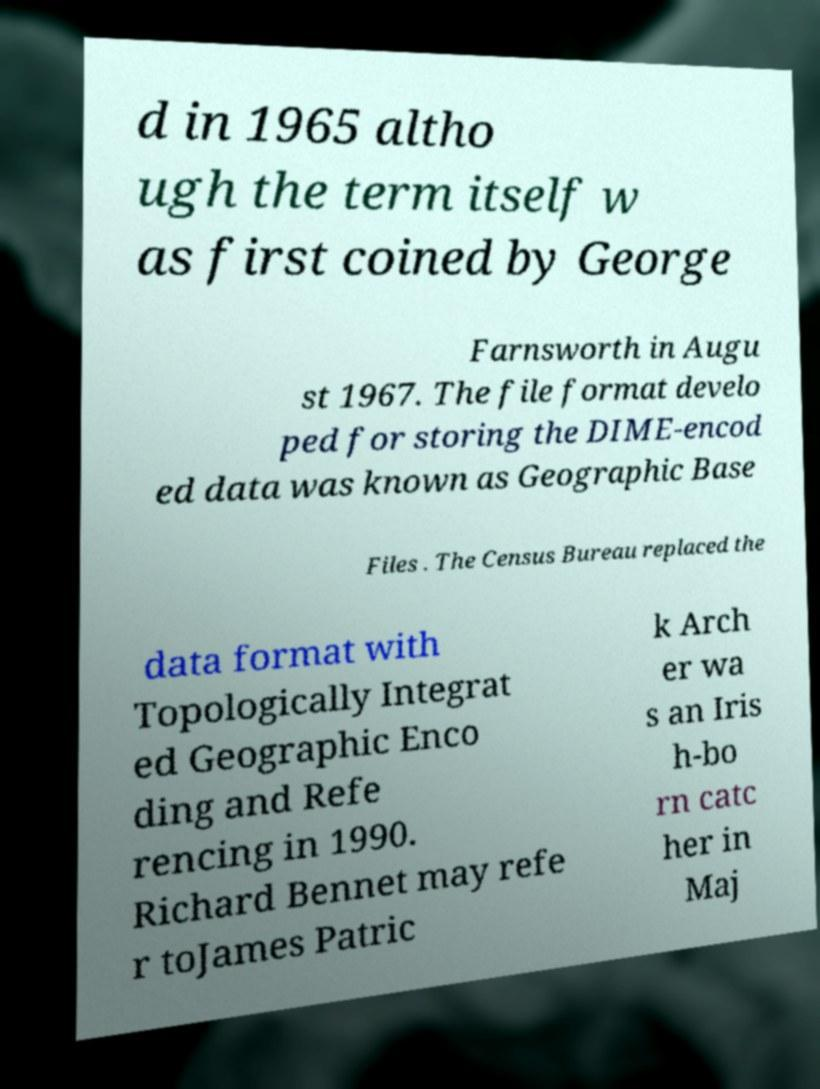Please read and relay the text visible in this image. What does it say? d in 1965 altho ugh the term itself w as first coined by George Farnsworth in Augu st 1967. The file format develo ped for storing the DIME-encod ed data was known as Geographic Base Files . The Census Bureau replaced the data format with Topologically Integrat ed Geographic Enco ding and Refe rencing in 1990. Richard Bennet may refe r toJames Patric k Arch er wa s an Iris h-bo rn catc her in Maj 